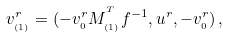Convert formula to latex. <formula><loc_0><loc_0><loc_500><loc_500>v _ { _ { ( 1 ) } } ^ { r } = ( - v _ { _ { 0 } } ^ { r } M _ { _ { ( 1 ) } } ^ { ^ { T } } f ^ { - 1 } , u ^ { r } , - v _ { _ { 0 } } ^ { r } ) \, ,</formula> 